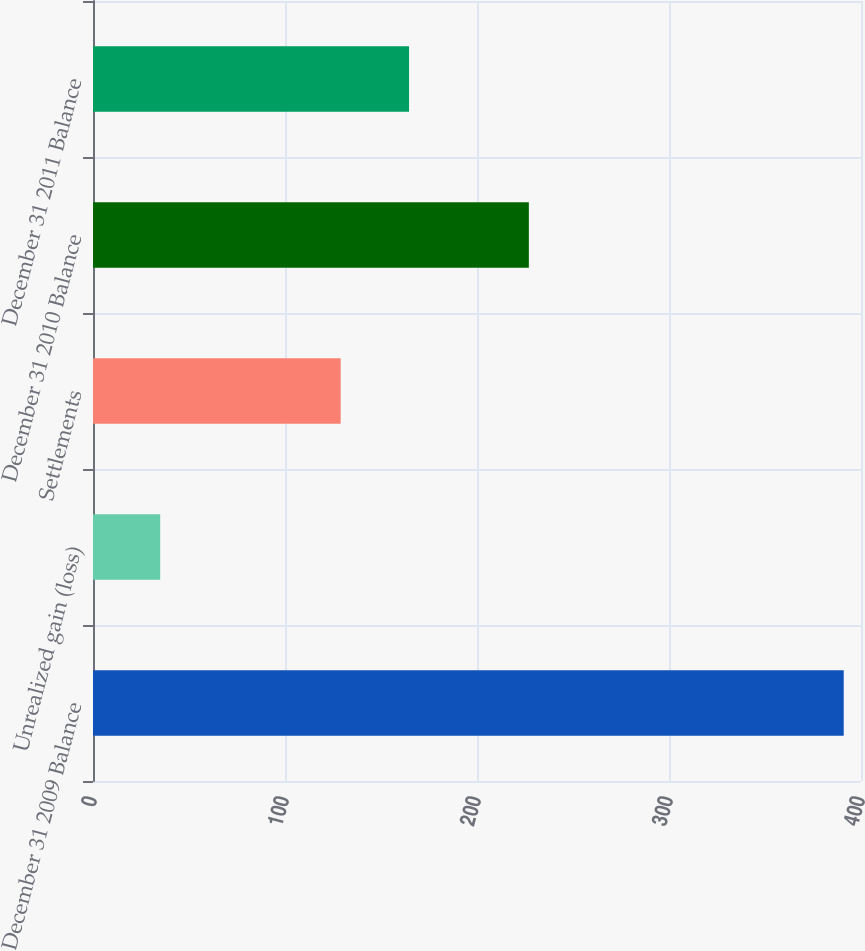Convert chart to OTSL. <chart><loc_0><loc_0><loc_500><loc_500><bar_chart><fcel>December 31 2009 Balance<fcel>Unrealized gain (loss)<fcel>Settlements<fcel>December 31 2010 Balance<fcel>December 31 2011 Balance<nl><fcel>391<fcel>35<fcel>129<fcel>227<fcel>164.6<nl></chart> 